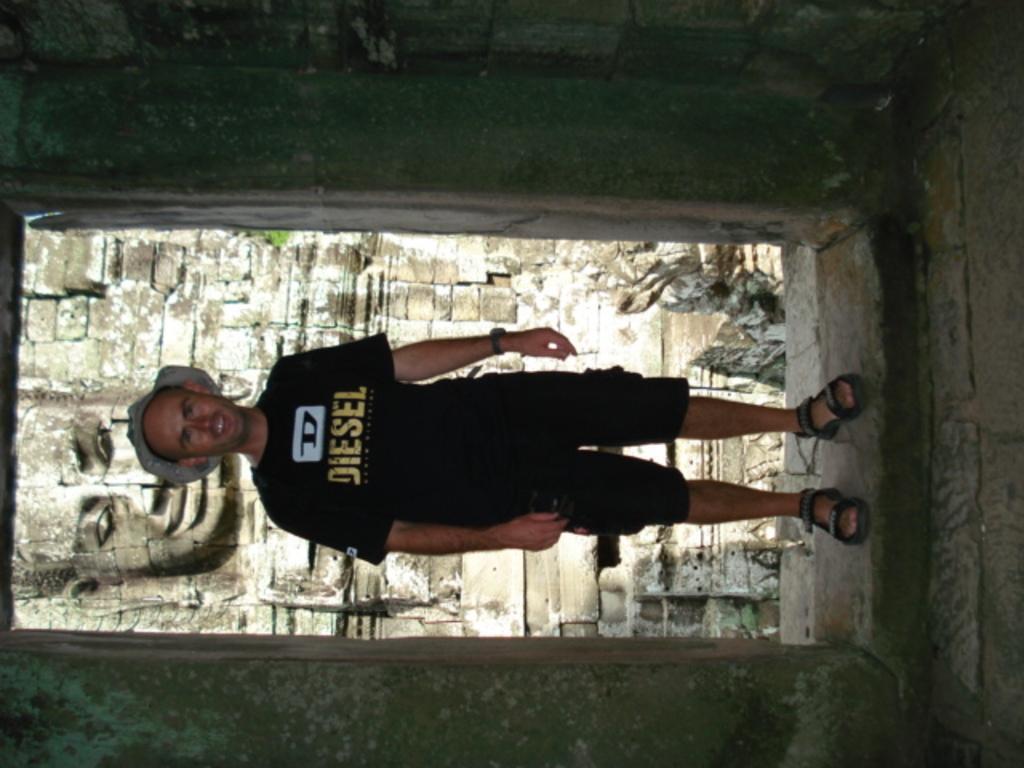Describe this image in one or two sentences. In the picture there is a man standing, he is wearing a hat, behind the man there is a sculptor present on the wall. 